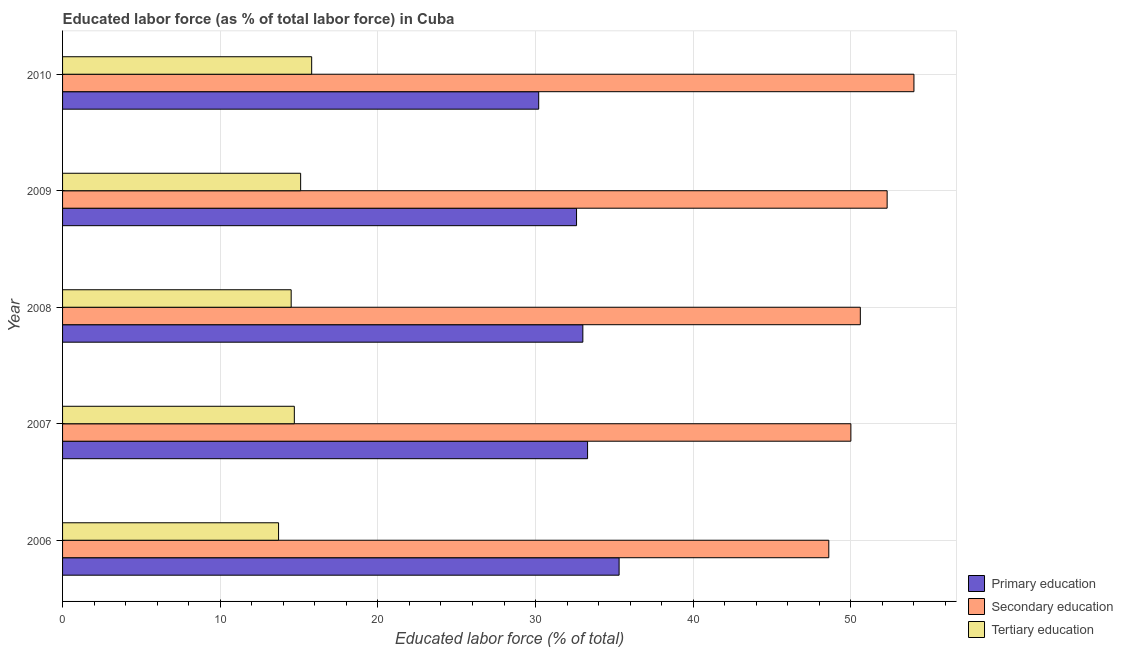Are the number of bars on each tick of the Y-axis equal?
Offer a very short reply. Yes. In how many cases, is the number of bars for a given year not equal to the number of legend labels?
Give a very brief answer. 0. What is the percentage of labor force who received primary education in 2009?
Keep it short and to the point. 32.6. Across all years, what is the minimum percentage of labor force who received primary education?
Give a very brief answer. 30.2. What is the total percentage of labor force who received tertiary education in the graph?
Your answer should be compact. 73.8. What is the difference between the percentage of labor force who received primary education in 2008 and that in 2010?
Provide a succinct answer. 2.8. What is the difference between the percentage of labor force who received secondary education in 2007 and the percentage of labor force who received tertiary education in 2009?
Your answer should be compact. 34.9. What is the average percentage of labor force who received secondary education per year?
Make the answer very short. 51.1. In the year 2007, what is the difference between the percentage of labor force who received tertiary education and percentage of labor force who received primary education?
Offer a very short reply. -18.6. Is the percentage of labor force who received secondary education in 2006 less than that in 2008?
Offer a very short reply. Yes. What is the difference between the highest and the second highest percentage of labor force who received secondary education?
Ensure brevity in your answer.  1.7. In how many years, is the percentage of labor force who received primary education greater than the average percentage of labor force who received primary education taken over all years?
Provide a succinct answer. 3. Is the sum of the percentage of labor force who received tertiary education in 2008 and 2010 greater than the maximum percentage of labor force who received primary education across all years?
Your response must be concise. No. What does the 1st bar from the top in 2009 represents?
Offer a very short reply. Tertiary education. What does the 3rd bar from the bottom in 2009 represents?
Make the answer very short. Tertiary education. What is the difference between two consecutive major ticks on the X-axis?
Keep it short and to the point. 10. Are the values on the major ticks of X-axis written in scientific E-notation?
Provide a short and direct response. No. How are the legend labels stacked?
Offer a terse response. Vertical. What is the title of the graph?
Keep it short and to the point. Educated labor force (as % of total labor force) in Cuba. Does "Ores and metals" appear as one of the legend labels in the graph?
Your answer should be compact. No. What is the label or title of the X-axis?
Provide a short and direct response. Educated labor force (% of total). What is the Educated labor force (% of total) in Primary education in 2006?
Give a very brief answer. 35.3. What is the Educated labor force (% of total) in Secondary education in 2006?
Make the answer very short. 48.6. What is the Educated labor force (% of total) in Tertiary education in 2006?
Keep it short and to the point. 13.7. What is the Educated labor force (% of total) in Primary education in 2007?
Offer a terse response. 33.3. What is the Educated labor force (% of total) of Tertiary education in 2007?
Keep it short and to the point. 14.7. What is the Educated labor force (% of total) in Secondary education in 2008?
Your response must be concise. 50.6. What is the Educated labor force (% of total) of Tertiary education in 2008?
Make the answer very short. 14.5. What is the Educated labor force (% of total) in Primary education in 2009?
Provide a short and direct response. 32.6. What is the Educated labor force (% of total) in Secondary education in 2009?
Offer a very short reply. 52.3. What is the Educated labor force (% of total) of Tertiary education in 2009?
Your response must be concise. 15.1. What is the Educated labor force (% of total) in Primary education in 2010?
Your answer should be very brief. 30.2. What is the Educated labor force (% of total) in Secondary education in 2010?
Provide a succinct answer. 54. What is the Educated labor force (% of total) of Tertiary education in 2010?
Make the answer very short. 15.8. Across all years, what is the maximum Educated labor force (% of total) of Primary education?
Your answer should be compact. 35.3. Across all years, what is the maximum Educated labor force (% of total) of Tertiary education?
Keep it short and to the point. 15.8. Across all years, what is the minimum Educated labor force (% of total) in Primary education?
Your answer should be very brief. 30.2. Across all years, what is the minimum Educated labor force (% of total) in Secondary education?
Your answer should be very brief. 48.6. Across all years, what is the minimum Educated labor force (% of total) in Tertiary education?
Provide a short and direct response. 13.7. What is the total Educated labor force (% of total) in Primary education in the graph?
Offer a terse response. 164.4. What is the total Educated labor force (% of total) in Secondary education in the graph?
Offer a terse response. 255.5. What is the total Educated labor force (% of total) in Tertiary education in the graph?
Provide a succinct answer. 73.8. What is the difference between the Educated labor force (% of total) of Secondary education in 2006 and that in 2007?
Make the answer very short. -1.4. What is the difference between the Educated labor force (% of total) of Primary education in 2006 and that in 2008?
Your answer should be very brief. 2.3. What is the difference between the Educated labor force (% of total) in Secondary education in 2006 and that in 2008?
Give a very brief answer. -2. What is the difference between the Educated labor force (% of total) in Tertiary education in 2006 and that in 2008?
Your answer should be very brief. -0.8. What is the difference between the Educated labor force (% of total) of Tertiary education in 2006 and that in 2009?
Give a very brief answer. -1.4. What is the difference between the Educated labor force (% of total) in Primary education in 2006 and that in 2010?
Offer a terse response. 5.1. What is the difference between the Educated labor force (% of total) in Tertiary education in 2006 and that in 2010?
Offer a very short reply. -2.1. What is the difference between the Educated labor force (% of total) of Primary education in 2007 and that in 2008?
Offer a very short reply. 0.3. What is the difference between the Educated labor force (% of total) of Secondary education in 2007 and that in 2008?
Keep it short and to the point. -0.6. What is the difference between the Educated labor force (% of total) in Tertiary education in 2007 and that in 2008?
Provide a short and direct response. 0.2. What is the difference between the Educated labor force (% of total) of Primary education in 2007 and that in 2010?
Ensure brevity in your answer.  3.1. What is the difference between the Educated labor force (% of total) in Tertiary education in 2007 and that in 2010?
Make the answer very short. -1.1. What is the difference between the Educated labor force (% of total) of Primary education in 2008 and that in 2010?
Provide a short and direct response. 2.8. What is the difference between the Educated labor force (% of total) of Secondary education in 2008 and that in 2010?
Offer a very short reply. -3.4. What is the difference between the Educated labor force (% of total) of Tertiary education in 2008 and that in 2010?
Offer a terse response. -1.3. What is the difference between the Educated labor force (% of total) in Tertiary education in 2009 and that in 2010?
Your answer should be compact. -0.7. What is the difference between the Educated labor force (% of total) of Primary education in 2006 and the Educated labor force (% of total) of Secondary education in 2007?
Give a very brief answer. -14.7. What is the difference between the Educated labor force (% of total) of Primary education in 2006 and the Educated labor force (% of total) of Tertiary education in 2007?
Give a very brief answer. 20.6. What is the difference between the Educated labor force (% of total) in Secondary education in 2006 and the Educated labor force (% of total) in Tertiary education in 2007?
Your answer should be compact. 33.9. What is the difference between the Educated labor force (% of total) in Primary education in 2006 and the Educated labor force (% of total) in Secondary education in 2008?
Ensure brevity in your answer.  -15.3. What is the difference between the Educated labor force (% of total) of Primary education in 2006 and the Educated labor force (% of total) of Tertiary education in 2008?
Provide a short and direct response. 20.8. What is the difference between the Educated labor force (% of total) in Secondary education in 2006 and the Educated labor force (% of total) in Tertiary education in 2008?
Offer a terse response. 34.1. What is the difference between the Educated labor force (% of total) of Primary education in 2006 and the Educated labor force (% of total) of Tertiary education in 2009?
Make the answer very short. 20.2. What is the difference between the Educated labor force (% of total) of Secondary education in 2006 and the Educated labor force (% of total) of Tertiary education in 2009?
Ensure brevity in your answer.  33.5. What is the difference between the Educated labor force (% of total) of Primary education in 2006 and the Educated labor force (% of total) of Secondary education in 2010?
Offer a terse response. -18.7. What is the difference between the Educated labor force (% of total) of Secondary education in 2006 and the Educated labor force (% of total) of Tertiary education in 2010?
Your answer should be compact. 32.8. What is the difference between the Educated labor force (% of total) in Primary education in 2007 and the Educated labor force (% of total) in Secondary education in 2008?
Your answer should be compact. -17.3. What is the difference between the Educated labor force (% of total) in Secondary education in 2007 and the Educated labor force (% of total) in Tertiary education in 2008?
Provide a short and direct response. 35.5. What is the difference between the Educated labor force (% of total) of Primary education in 2007 and the Educated labor force (% of total) of Tertiary education in 2009?
Make the answer very short. 18.2. What is the difference between the Educated labor force (% of total) of Secondary education in 2007 and the Educated labor force (% of total) of Tertiary education in 2009?
Make the answer very short. 34.9. What is the difference between the Educated labor force (% of total) in Primary education in 2007 and the Educated labor force (% of total) in Secondary education in 2010?
Make the answer very short. -20.7. What is the difference between the Educated labor force (% of total) in Primary education in 2007 and the Educated labor force (% of total) in Tertiary education in 2010?
Your response must be concise. 17.5. What is the difference between the Educated labor force (% of total) of Secondary education in 2007 and the Educated labor force (% of total) of Tertiary education in 2010?
Offer a very short reply. 34.2. What is the difference between the Educated labor force (% of total) of Primary education in 2008 and the Educated labor force (% of total) of Secondary education in 2009?
Ensure brevity in your answer.  -19.3. What is the difference between the Educated labor force (% of total) of Primary education in 2008 and the Educated labor force (% of total) of Tertiary education in 2009?
Ensure brevity in your answer.  17.9. What is the difference between the Educated labor force (% of total) of Secondary education in 2008 and the Educated labor force (% of total) of Tertiary education in 2009?
Your response must be concise. 35.5. What is the difference between the Educated labor force (% of total) in Primary education in 2008 and the Educated labor force (% of total) in Secondary education in 2010?
Your answer should be very brief. -21. What is the difference between the Educated labor force (% of total) of Primary education in 2008 and the Educated labor force (% of total) of Tertiary education in 2010?
Provide a succinct answer. 17.2. What is the difference between the Educated labor force (% of total) in Secondary education in 2008 and the Educated labor force (% of total) in Tertiary education in 2010?
Offer a very short reply. 34.8. What is the difference between the Educated labor force (% of total) in Primary education in 2009 and the Educated labor force (% of total) in Secondary education in 2010?
Your answer should be very brief. -21.4. What is the difference between the Educated labor force (% of total) in Secondary education in 2009 and the Educated labor force (% of total) in Tertiary education in 2010?
Your answer should be very brief. 36.5. What is the average Educated labor force (% of total) of Primary education per year?
Your response must be concise. 32.88. What is the average Educated labor force (% of total) in Secondary education per year?
Your answer should be very brief. 51.1. What is the average Educated labor force (% of total) in Tertiary education per year?
Make the answer very short. 14.76. In the year 2006, what is the difference between the Educated labor force (% of total) of Primary education and Educated labor force (% of total) of Tertiary education?
Your response must be concise. 21.6. In the year 2006, what is the difference between the Educated labor force (% of total) of Secondary education and Educated labor force (% of total) of Tertiary education?
Make the answer very short. 34.9. In the year 2007, what is the difference between the Educated labor force (% of total) of Primary education and Educated labor force (% of total) of Secondary education?
Your response must be concise. -16.7. In the year 2007, what is the difference between the Educated labor force (% of total) in Secondary education and Educated labor force (% of total) in Tertiary education?
Your answer should be compact. 35.3. In the year 2008, what is the difference between the Educated labor force (% of total) in Primary education and Educated labor force (% of total) in Secondary education?
Your answer should be very brief. -17.6. In the year 2008, what is the difference between the Educated labor force (% of total) of Primary education and Educated labor force (% of total) of Tertiary education?
Offer a very short reply. 18.5. In the year 2008, what is the difference between the Educated labor force (% of total) in Secondary education and Educated labor force (% of total) in Tertiary education?
Ensure brevity in your answer.  36.1. In the year 2009, what is the difference between the Educated labor force (% of total) in Primary education and Educated labor force (% of total) in Secondary education?
Offer a terse response. -19.7. In the year 2009, what is the difference between the Educated labor force (% of total) of Primary education and Educated labor force (% of total) of Tertiary education?
Provide a succinct answer. 17.5. In the year 2009, what is the difference between the Educated labor force (% of total) of Secondary education and Educated labor force (% of total) of Tertiary education?
Make the answer very short. 37.2. In the year 2010, what is the difference between the Educated labor force (% of total) of Primary education and Educated labor force (% of total) of Secondary education?
Your response must be concise. -23.8. In the year 2010, what is the difference between the Educated labor force (% of total) in Secondary education and Educated labor force (% of total) in Tertiary education?
Offer a terse response. 38.2. What is the ratio of the Educated labor force (% of total) of Primary education in 2006 to that in 2007?
Your response must be concise. 1.06. What is the ratio of the Educated labor force (% of total) of Secondary education in 2006 to that in 2007?
Make the answer very short. 0.97. What is the ratio of the Educated labor force (% of total) of Tertiary education in 2006 to that in 2007?
Make the answer very short. 0.93. What is the ratio of the Educated labor force (% of total) in Primary education in 2006 to that in 2008?
Keep it short and to the point. 1.07. What is the ratio of the Educated labor force (% of total) in Secondary education in 2006 to that in 2008?
Your answer should be compact. 0.96. What is the ratio of the Educated labor force (% of total) of Tertiary education in 2006 to that in 2008?
Your answer should be compact. 0.94. What is the ratio of the Educated labor force (% of total) in Primary education in 2006 to that in 2009?
Provide a short and direct response. 1.08. What is the ratio of the Educated labor force (% of total) in Secondary education in 2006 to that in 2009?
Make the answer very short. 0.93. What is the ratio of the Educated labor force (% of total) in Tertiary education in 2006 to that in 2009?
Give a very brief answer. 0.91. What is the ratio of the Educated labor force (% of total) in Primary education in 2006 to that in 2010?
Ensure brevity in your answer.  1.17. What is the ratio of the Educated labor force (% of total) in Tertiary education in 2006 to that in 2010?
Offer a very short reply. 0.87. What is the ratio of the Educated labor force (% of total) in Primary education in 2007 to that in 2008?
Make the answer very short. 1.01. What is the ratio of the Educated labor force (% of total) of Tertiary education in 2007 to that in 2008?
Give a very brief answer. 1.01. What is the ratio of the Educated labor force (% of total) of Primary education in 2007 to that in 2009?
Keep it short and to the point. 1.02. What is the ratio of the Educated labor force (% of total) in Secondary education in 2007 to that in 2009?
Make the answer very short. 0.96. What is the ratio of the Educated labor force (% of total) of Tertiary education in 2007 to that in 2009?
Give a very brief answer. 0.97. What is the ratio of the Educated labor force (% of total) in Primary education in 2007 to that in 2010?
Your response must be concise. 1.1. What is the ratio of the Educated labor force (% of total) of Secondary education in 2007 to that in 2010?
Your response must be concise. 0.93. What is the ratio of the Educated labor force (% of total) in Tertiary education in 2007 to that in 2010?
Your answer should be compact. 0.93. What is the ratio of the Educated labor force (% of total) in Primary education in 2008 to that in 2009?
Offer a very short reply. 1.01. What is the ratio of the Educated labor force (% of total) of Secondary education in 2008 to that in 2009?
Ensure brevity in your answer.  0.97. What is the ratio of the Educated labor force (% of total) in Tertiary education in 2008 to that in 2009?
Keep it short and to the point. 0.96. What is the ratio of the Educated labor force (% of total) in Primary education in 2008 to that in 2010?
Give a very brief answer. 1.09. What is the ratio of the Educated labor force (% of total) of Secondary education in 2008 to that in 2010?
Offer a very short reply. 0.94. What is the ratio of the Educated labor force (% of total) of Tertiary education in 2008 to that in 2010?
Your response must be concise. 0.92. What is the ratio of the Educated labor force (% of total) of Primary education in 2009 to that in 2010?
Offer a terse response. 1.08. What is the ratio of the Educated labor force (% of total) in Secondary education in 2009 to that in 2010?
Your answer should be compact. 0.97. What is the ratio of the Educated labor force (% of total) of Tertiary education in 2009 to that in 2010?
Give a very brief answer. 0.96. What is the difference between the highest and the second highest Educated labor force (% of total) in Primary education?
Give a very brief answer. 2. What is the difference between the highest and the second highest Educated labor force (% of total) in Secondary education?
Your answer should be compact. 1.7. What is the difference between the highest and the second highest Educated labor force (% of total) in Tertiary education?
Make the answer very short. 0.7. What is the difference between the highest and the lowest Educated labor force (% of total) of Tertiary education?
Offer a very short reply. 2.1. 